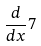<formula> <loc_0><loc_0><loc_500><loc_500>\frac { d } { d x } 7</formula> 